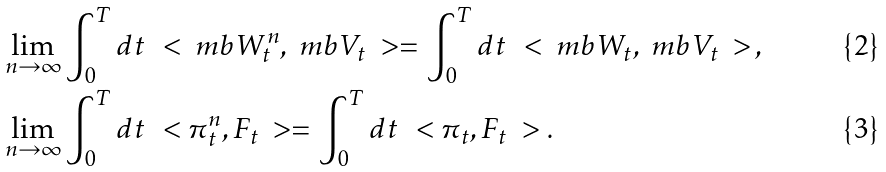<formula> <loc_0><loc_0><loc_500><loc_500>& \lim _ { n \to \infty } \int _ { 0 } ^ { T } d t \, \ < \ m b W ^ { n } _ { t } , \ m b V _ { t } \ > = \int _ { 0 } ^ { T } d t \, \ < \ m b W _ { t } , \ m b V _ { t } \ > \, , \\ & \lim _ { n \to \infty } \int _ { 0 } ^ { T } d t \, \ < \pi ^ { n } _ { t } , F _ { t } \ > = \int _ { 0 } ^ { T } d t \, \ < \pi _ { t } , F _ { t } \ > .</formula> 